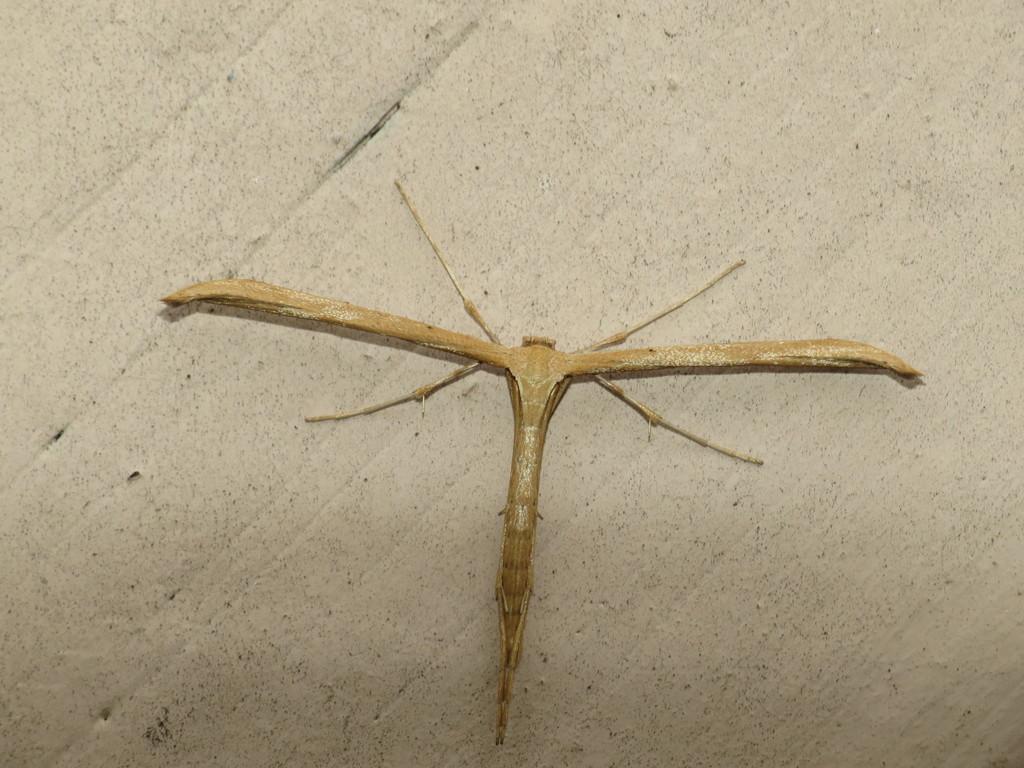How would you summarize this image in a sentence or two? In this image there is an insect on the wall, the background of the image is white. 